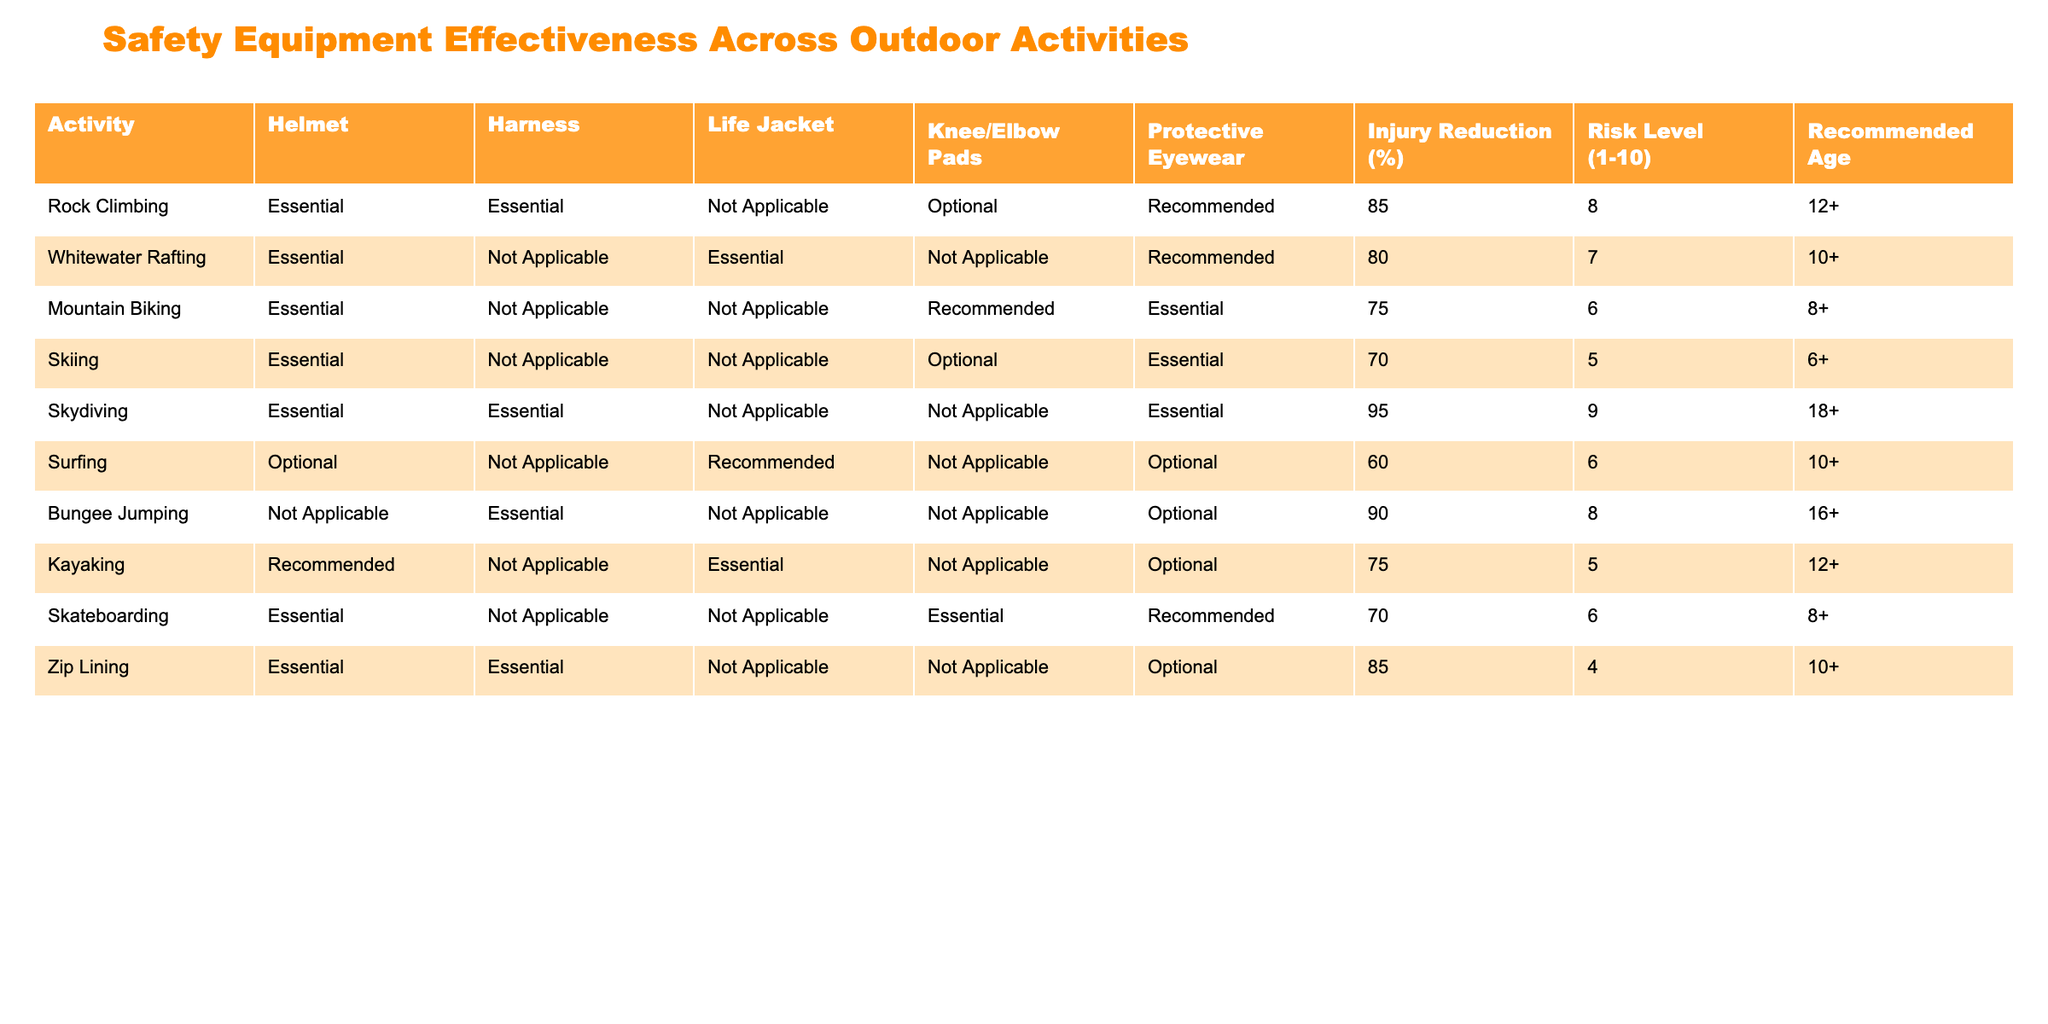What percentage of injury reduction is associated with skydiving? Skydiving has an injury reduction percentage listed in the table. Looking at the specific row for skydiving, the injury reduction value is 95%.
Answer: 95% Which activity has the lowest risk level? By examining the risk level column, we can distinguish that the lowest risk level is given to Zip Lining, which has a risk level of 4, the lowest value in the table.
Answer: 4 Is a helmet considered essential for mountain biking? The table indicates that a helmet is classified as essential for mountain biking. This can be found in the corresponding row for mountain biking under the helmet column.
Answer: Yes What is the average injury reduction percentage for activities that include a life jacket? First, we identify the activities that require a life jacket: Whitewater Rafting (80%), Kayaking (75%), and none for other activities. Adding these up, we have 80 + 75 = 155. There are 2 activities, so we divide by 2, giving us an average of 155/2 = 77.5%.
Answer: 77.5% Which two activities have the highest injury reduction percentages? Looking at the injury reduction percentages, Skydiving (95%) and Bungee Jumping (90%) have the highest values. They can be seen by checking the injury reduction column and identifying the top two entries.
Answer: Skydiving and Bungee Jumping Does surfing require protective eyewear according to the table? In the surfing row, the protective eyewear column states "Optional". Therefore, it is not mandatory but can be used if desired. This indicates that protective eyewear is not required.
Answer: No How many outdoor activities have harnesses deemed essential? By scanning the harness column, we find that essential harnesses are mentioned for Rock Climbing and Skydiving. Therefore, we note there are 2 activities with this classification.
Answer: 2 What is the risk level associated with skiing? The risk level for skiing is provided directly in its row, and that value is 5. Hence, no additional operations are needed to determine this information.
Answer: 5 Which activity recommended for ages 12 and older has the highest injury reduction percentage? Among the activities listed for 12 and older, we see Rock Climbing (85%) and Kayaking (75%). Comparing these gives us that Rock Climbing has the highest injury reduction percentage for this age group.
Answer: Rock Climbing 